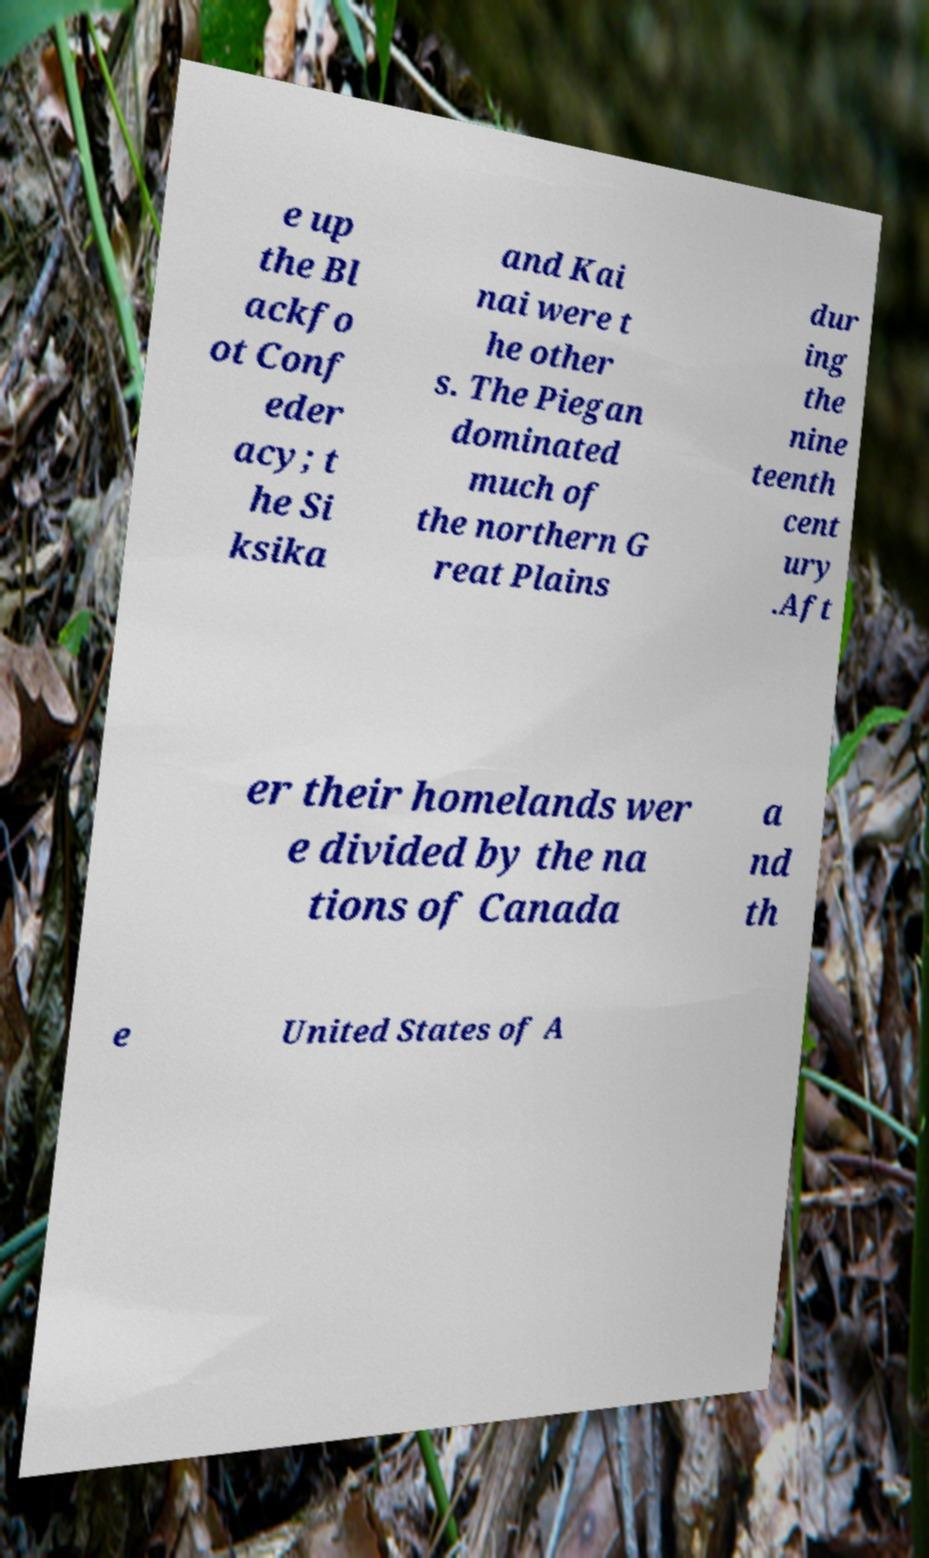Can you accurately transcribe the text from the provided image for me? e up the Bl ackfo ot Conf eder acy; t he Si ksika and Kai nai were t he other s. The Piegan dominated much of the northern G reat Plains dur ing the nine teenth cent ury .Aft er their homelands wer e divided by the na tions of Canada a nd th e United States of A 